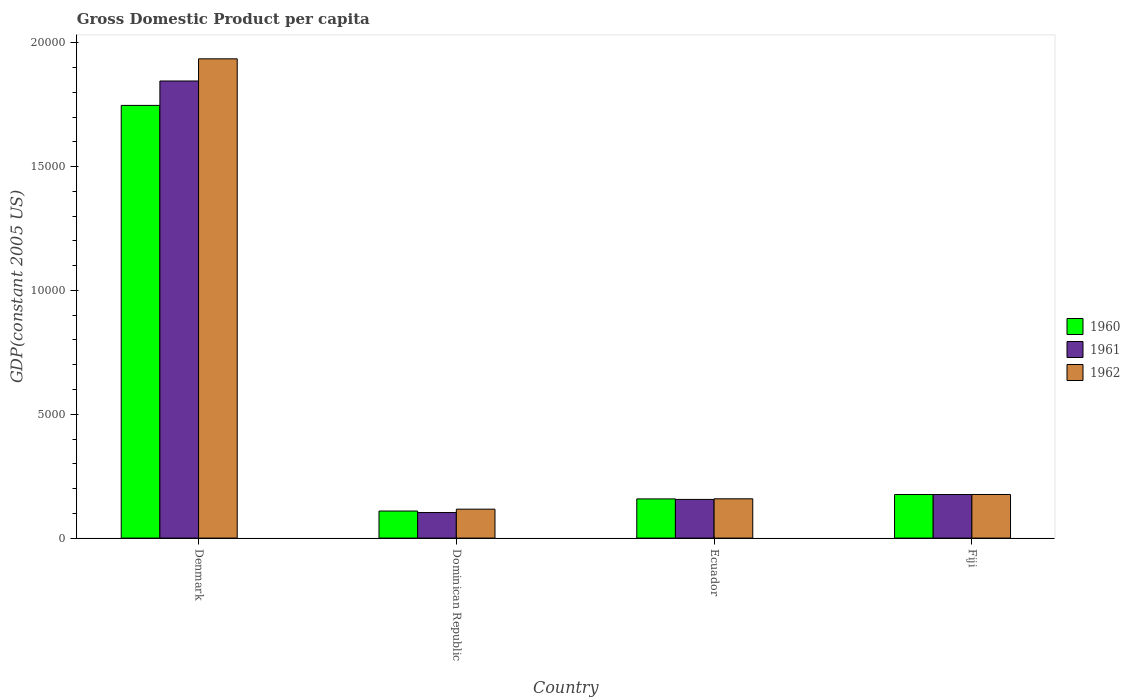Are the number of bars per tick equal to the number of legend labels?
Your answer should be very brief. Yes. Are the number of bars on each tick of the X-axis equal?
Provide a short and direct response. Yes. What is the label of the 2nd group of bars from the left?
Offer a terse response. Dominican Republic. In how many cases, is the number of bars for a given country not equal to the number of legend labels?
Provide a succinct answer. 0. What is the GDP per capita in 1962 in Denmark?
Your answer should be compact. 1.94e+04. Across all countries, what is the maximum GDP per capita in 1961?
Ensure brevity in your answer.  1.85e+04. Across all countries, what is the minimum GDP per capita in 1962?
Ensure brevity in your answer.  1168.23. In which country was the GDP per capita in 1960 maximum?
Give a very brief answer. Denmark. In which country was the GDP per capita in 1960 minimum?
Ensure brevity in your answer.  Dominican Republic. What is the total GDP per capita in 1961 in the graph?
Ensure brevity in your answer.  2.28e+04. What is the difference between the GDP per capita in 1961 in Denmark and that in Dominican Republic?
Offer a very short reply. 1.74e+04. What is the difference between the GDP per capita in 1960 in Fiji and the GDP per capita in 1961 in Denmark?
Keep it short and to the point. -1.67e+04. What is the average GDP per capita in 1960 per country?
Offer a terse response. 5476.6. What is the difference between the GDP per capita of/in 1962 and GDP per capita of/in 1961 in Denmark?
Your answer should be compact. 894.72. What is the ratio of the GDP per capita in 1960 in Dominican Republic to that in Ecuador?
Your answer should be compact. 0.69. Is the GDP per capita in 1962 in Dominican Republic less than that in Fiji?
Provide a short and direct response. Yes. What is the difference between the highest and the second highest GDP per capita in 1962?
Provide a succinct answer. 1.76e+04. What is the difference between the highest and the lowest GDP per capita in 1960?
Your answer should be very brief. 1.64e+04. What does the 3rd bar from the left in Fiji represents?
Offer a very short reply. 1962. Is it the case that in every country, the sum of the GDP per capita in 1961 and GDP per capita in 1962 is greater than the GDP per capita in 1960?
Your response must be concise. Yes. How many bars are there?
Provide a succinct answer. 12. What is the difference between two consecutive major ticks on the Y-axis?
Offer a terse response. 5000. Are the values on the major ticks of Y-axis written in scientific E-notation?
Offer a terse response. No. Where does the legend appear in the graph?
Give a very brief answer. Center right. How many legend labels are there?
Keep it short and to the point. 3. How are the legend labels stacked?
Make the answer very short. Vertical. What is the title of the graph?
Offer a very short reply. Gross Domestic Product per capita. What is the label or title of the X-axis?
Offer a very short reply. Country. What is the label or title of the Y-axis?
Give a very brief answer. GDP(constant 2005 US). What is the GDP(constant 2005 US) of 1960 in Denmark?
Your answer should be very brief. 1.75e+04. What is the GDP(constant 2005 US) in 1961 in Denmark?
Provide a succinct answer. 1.85e+04. What is the GDP(constant 2005 US) in 1962 in Denmark?
Your answer should be very brief. 1.94e+04. What is the GDP(constant 2005 US) in 1960 in Dominican Republic?
Provide a succinct answer. 1092.2. What is the GDP(constant 2005 US) in 1961 in Dominican Republic?
Offer a terse response. 1031.78. What is the GDP(constant 2005 US) in 1962 in Dominican Republic?
Offer a terse response. 1168.23. What is the GDP(constant 2005 US) of 1960 in Ecuador?
Make the answer very short. 1582.31. What is the GDP(constant 2005 US) of 1961 in Ecuador?
Make the answer very short. 1561.61. What is the GDP(constant 2005 US) of 1962 in Ecuador?
Your response must be concise. 1586.66. What is the GDP(constant 2005 US) in 1960 in Fiji?
Ensure brevity in your answer.  1759.58. What is the GDP(constant 2005 US) of 1961 in Fiji?
Provide a short and direct response. 1759.88. What is the GDP(constant 2005 US) in 1962 in Fiji?
Offer a very short reply. 1760.96. Across all countries, what is the maximum GDP(constant 2005 US) of 1960?
Offer a very short reply. 1.75e+04. Across all countries, what is the maximum GDP(constant 2005 US) of 1961?
Your answer should be compact. 1.85e+04. Across all countries, what is the maximum GDP(constant 2005 US) of 1962?
Offer a very short reply. 1.94e+04. Across all countries, what is the minimum GDP(constant 2005 US) in 1960?
Provide a succinct answer. 1092.2. Across all countries, what is the minimum GDP(constant 2005 US) in 1961?
Provide a succinct answer. 1031.78. Across all countries, what is the minimum GDP(constant 2005 US) in 1962?
Offer a terse response. 1168.23. What is the total GDP(constant 2005 US) in 1960 in the graph?
Keep it short and to the point. 2.19e+04. What is the total GDP(constant 2005 US) in 1961 in the graph?
Keep it short and to the point. 2.28e+04. What is the total GDP(constant 2005 US) of 1962 in the graph?
Provide a succinct answer. 2.39e+04. What is the difference between the GDP(constant 2005 US) of 1960 in Denmark and that in Dominican Republic?
Provide a short and direct response. 1.64e+04. What is the difference between the GDP(constant 2005 US) of 1961 in Denmark and that in Dominican Republic?
Offer a terse response. 1.74e+04. What is the difference between the GDP(constant 2005 US) in 1962 in Denmark and that in Dominican Republic?
Your answer should be very brief. 1.82e+04. What is the difference between the GDP(constant 2005 US) of 1960 in Denmark and that in Ecuador?
Make the answer very short. 1.59e+04. What is the difference between the GDP(constant 2005 US) in 1961 in Denmark and that in Ecuador?
Make the answer very short. 1.69e+04. What is the difference between the GDP(constant 2005 US) of 1962 in Denmark and that in Ecuador?
Your answer should be compact. 1.78e+04. What is the difference between the GDP(constant 2005 US) of 1960 in Denmark and that in Fiji?
Your response must be concise. 1.57e+04. What is the difference between the GDP(constant 2005 US) of 1961 in Denmark and that in Fiji?
Keep it short and to the point. 1.67e+04. What is the difference between the GDP(constant 2005 US) of 1962 in Denmark and that in Fiji?
Provide a succinct answer. 1.76e+04. What is the difference between the GDP(constant 2005 US) in 1960 in Dominican Republic and that in Ecuador?
Provide a short and direct response. -490.11. What is the difference between the GDP(constant 2005 US) of 1961 in Dominican Republic and that in Ecuador?
Your answer should be compact. -529.84. What is the difference between the GDP(constant 2005 US) in 1962 in Dominican Republic and that in Ecuador?
Your answer should be very brief. -418.42. What is the difference between the GDP(constant 2005 US) in 1960 in Dominican Republic and that in Fiji?
Keep it short and to the point. -667.38. What is the difference between the GDP(constant 2005 US) in 1961 in Dominican Republic and that in Fiji?
Keep it short and to the point. -728.1. What is the difference between the GDP(constant 2005 US) of 1962 in Dominican Republic and that in Fiji?
Offer a terse response. -592.72. What is the difference between the GDP(constant 2005 US) in 1960 in Ecuador and that in Fiji?
Provide a short and direct response. -177.27. What is the difference between the GDP(constant 2005 US) in 1961 in Ecuador and that in Fiji?
Offer a terse response. -198.26. What is the difference between the GDP(constant 2005 US) in 1962 in Ecuador and that in Fiji?
Your response must be concise. -174.3. What is the difference between the GDP(constant 2005 US) of 1960 in Denmark and the GDP(constant 2005 US) of 1961 in Dominican Republic?
Ensure brevity in your answer.  1.64e+04. What is the difference between the GDP(constant 2005 US) of 1960 in Denmark and the GDP(constant 2005 US) of 1962 in Dominican Republic?
Offer a very short reply. 1.63e+04. What is the difference between the GDP(constant 2005 US) in 1961 in Denmark and the GDP(constant 2005 US) in 1962 in Dominican Republic?
Keep it short and to the point. 1.73e+04. What is the difference between the GDP(constant 2005 US) of 1960 in Denmark and the GDP(constant 2005 US) of 1961 in Ecuador?
Make the answer very short. 1.59e+04. What is the difference between the GDP(constant 2005 US) of 1960 in Denmark and the GDP(constant 2005 US) of 1962 in Ecuador?
Keep it short and to the point. 1.59e+04. What is the difference between the GDP(constant 2005 US) in 1961 in Denmark and the GDP(constant 2005 US) in 1962 in Ecuador?
Give a very brief answer. 1.69e+04. What is the difference between the GDP(constant 2005 US) in 1960 in Denmark and the GDP(constant 2005 US) in 1961 in Fiji?
Provide a succinct answer. 1.57e+04. What is the difference between the GDP(constant 2005 US) of 1960 in Denmark and the GDP(constant 2005 US) of 1962 in Fiji?
Provide a short and direct response. 1.57e+04. What is the difference between the GDP(constant 2005 US) in 1961 in Denmark and the GDP(constant 2005 US) in 1962 in Fiji?
Provide a succinct answer. 1.67e+04. What is the difference between the GDP(constant 2005 US) in 1960 in Dominican Republic and the GDP(constant 2005 US) in 1961 in Ecuador?
Offer a very short reply. -469.41. What is the difference between the GDP(constant 2005 US) of 1960 in Dominican Republic and the GDP(constant 2005 US) of 1962 in Ecuador?
Your answer should be very brief. -494.45. What is the difference between the GDP(constant 2005 US) in 1961 in Dominican Republic and the GDP(constant 2005 US) in 1962 in Ecuador?
Keep it short and to the point. -554.88. What is the difference between the GDP(constant 2005 US) of 1960 in Dominican Republic and the GDP(constant 2005 US) of 1961 in Fiji?
Provide a short and direct response. -667.67. What is the difference between the GDP(constant 2005 US) in 1960 in Dominican Republic and the GDP(constant 2005 US) in 1962 in Fiji?
Give a very brief answer. -668.75. What is the difference between the GDP(constant 2005 US) of 1961 in Dominican Republic and the GDP(constant 2005 US) of 1962 in Fiji?
Keep it short and to the point. -729.18. What is the difference between the GDP(constant 2005 US) of 1960 in Ecuador and the GDP(constant 2005 US) of 1961 in Fiji?
Your answer should be compact. -177.57. What is the difference between the GDP(constant 2005 US) of 1960 in Ecuador and the GDP(constant 2005 US) of 1962 in Fiji?
Make the answer very short. -178.65. What is the difference between the GDP(constant 2005 US) in 1961 in Ecuador and the GDP(constant 2005 US) in 1962 in Fiji?
Provide a succinct answer. -199.34. What is the average GDP(constant 2005 US) of 1960 per country?
Ensure brevity in your answer.  5476.6. What is the average GDP(constant 2005 US) of 1961 per country?
Keep it short and to the point. 5702.7. What is the average GDP(constant 2005 US) in 1962 per country?
Give a very brief answer. 5967.03. What is the difference between the GDP(constant 2005 US) of 1960 and GDP(constant 2005 US) of 1961 in Denmark?
Ensure brevity in your answer.  -985.22. What is the difference between the GDP(constant 2005 US) in 1960 and GDP(constant 2005 US) in 1962 in Denmark?
Provide a short and direct response. -1879.94. What is the difference between the GDP(constant 2005 US) of 1961 and GDP(constant 2005 US) of 1962 in Denmark?
Provide a succinct answer. -894.72. What is the difference between the GDP(constant 2005 US) in 1960 and GDP(constant 2005 US) in 1961 in Dominican Republic?
Your answer should be compact. 60.43. What is the difference between the GDP(constant 2005 US) in 1960 and GDP(constant 2005 US) in 1962 in Dominican Republic?
Offer a terse response. -76.03. What is the difference between the GDP(constant 2005 US) in 1961 and GDP(constant 2005 US) in 1962 in Dominican Republic?
Make the answer very short. -136.46. What is the difference between the GDP(constant 2005 US) of 1960 and GDP(constant 2005 US) of 1961 in Ecuador?
Ensure brevity in your answer.  20.7. What is the difference between the GDP(constant 2005 US) in 1960 and GDP(constant 2005 US) in 1962 in Ecuador?
Keep it short and to the point. -4.35. What is the difference between the GDP(constant 2005 US) of 1961 and GDP(constant 2005 US) of 1962 in Ecuador?
Offer a terse response. -25.04. What is the difference between the GDP(constant 2005 US) of 1960 and GDP(constant 2005 US) of 1961 in Fiji?
Your answer should be very brief. -0.3. What is the difference between the GDP(constant 2005 US) of 1960 and GDP(constant 2005 US) of 1962 in Fiji?
Offer a terse response. -1.37. What is the difference between the GDP(constant 2005 US) of 1961 and GDP(constant 2005 US) of 1962 in Fiji?
Keep it short and to the point. -1.08. What is the ratio of the GDP(constant 2005 US) of 1960 in Denmark to that in Dominican Republic?
Your answer should be compact. 16. What is the ratio of the GDP(constant 2005 US) in 1961 in Denmark to that in Dominican Republic?
Your answer should be very brief. 17.89. What is the ratio of the GDP(constant 2005 US) in 1962 in Denmark to that in Dominican Republic?
Your answer should be compact. 16.57. What is the ratio of the GDP(constant 2005 US) in 1960 in Denmark to that in Ecuador?
Keep it short and to the point. 11.04. What is the ratio of the GDP(constant 2005 US) of 1961 in Denmark to that in Ecuador?
Ensure brevity in your answer.  11.82. What is the ratio of the GDP(constant 2005 US) of 1962 in Denmark to that in Ecuador?
Your response must be concise. 12.2. What is the ratio of the GDP(constant 2005 US) of 1960 in Denmark to that in Fiji?
Offer a very short reply. 9.93. What is the ratio of the GDP(constant 2005 US) of 1961 in Denmark to that in Fiji?
Offer a terse response. 10.49. What is the ratio of the GDP(constant 2005 US) of 1962 in Denmark to that in Fiji?
Your answer should be compact. 10.99. What is the ratio of the GDP(constant 2005 US) in 1960 in Dominican Republic to that in Ecuador?
Provide a short and direct response. 0.69. What is the ratio of the GDP(constant 2005 US) of 1961 in Dominican Republic to that in Ecuador?
Keep it short and to the point. 0.66. What is the ratio of the GDP(constant 2005 US) in 1962 in Dominican Republic to that in Ecuador?
Make the answer very short. 0.74. What is the ratio of the GDP(constant 2005 US) in 1960 in Dominican Republic to that in Fiji?
Your answer should be very brief. 0.62. What is the ratio of the GDP(constant 2005 US) of 1961 in Dominican Republic to that in Fiji?
Provide a succinct answer. 0.59. What is the ratio of the GDP(constant 2005 US) of 1962 in Dominican Republic to that in Fiji?
Offer a terse response. 0.66. What is the ratio of the GDP(constant 2005 US) of 1960 in Ecuador to that in Fiji?
Your response must be concise. 0.9. What is the ratio of the GDP(constant 2005 US) of 1961 in Ecuador to that in Fiji?
Provide a succinct answer. 0.89. What is the ratio of the GDP(constant 2005 US) in 1962 in Ecuador to that in Fiji?
Your response must be concise. 0.9. What is the difference between the highest and the second highest GDP(constant 2005 US) of 1960?
Provide a succinct answer. 1.57e+04. What is the difference between the highest and the second highest GDP(constant 2005 US) in 1961?
Offer a terse response. 1.67e+04. What is the difference between the highest and the second highest GDP(constant 2005 US) of 1962?
Provide a succinct answer. 1.76e+04. What is the difference between the highest and the lowest GDP(constant 2005 US) in 1960?
Offer a terse response. 1.64e+04. What is the difference between the highest and the lowest GDP(constant 2005 US) in 1961?
Give a very brief answer. 1.74e+04. What is the difference between the highest and the lowest GDP(constant 2005 US) in 1962?
Your answer should be very brief. 1.82e+04. 